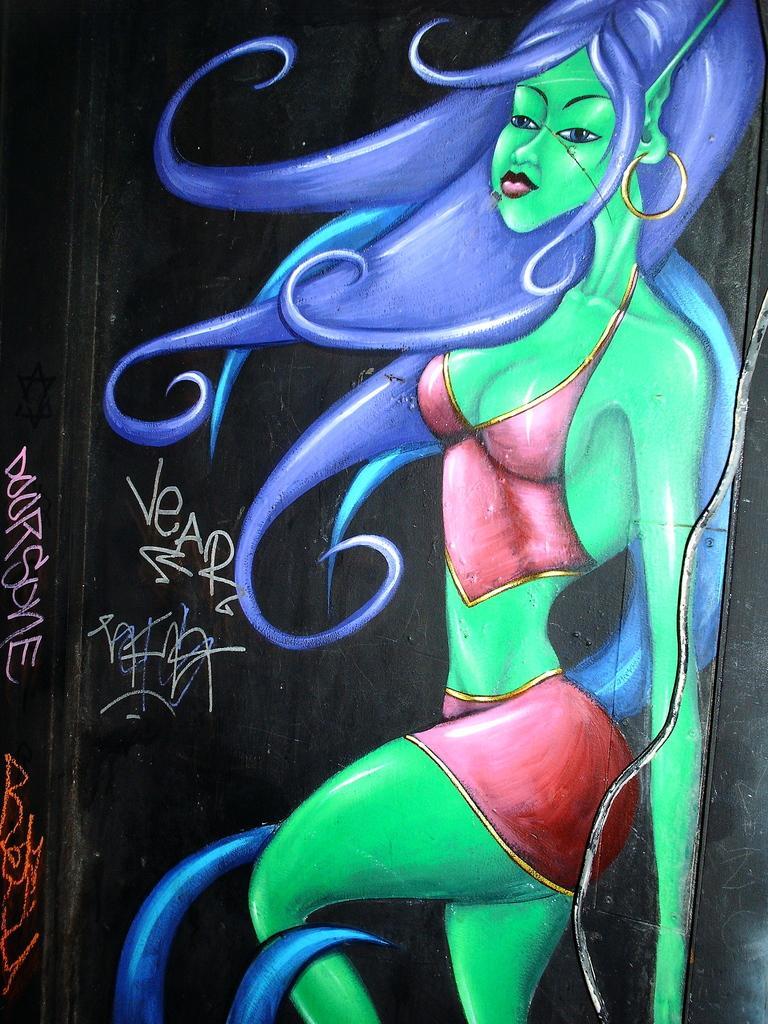Could you give a brief overview of what you see in this image? In this picture I can see the depiction of cartoon character of a woman who is wearing red color dress and I see something is written on the left side of this image and I see the black color thing. 